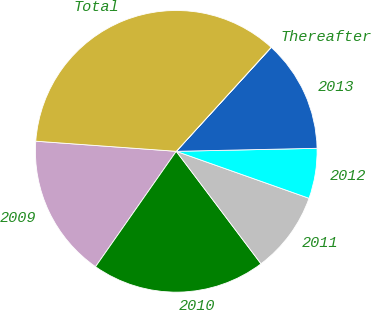<chart> <loc_0><loc_0><loc_500><loc_500><pie_chart><fcel>2009<fcel>2010<fcel>2011<fcel>2012<fcel>2013<fcel>Thereafter<fcel>Total<nl><fcel>16.43%<fcel>19.99%<fcel>9.31%<fcel>5.75%<fcel>12.87%<fcel>0.02%<fcel>35.62%<nl></chart> 